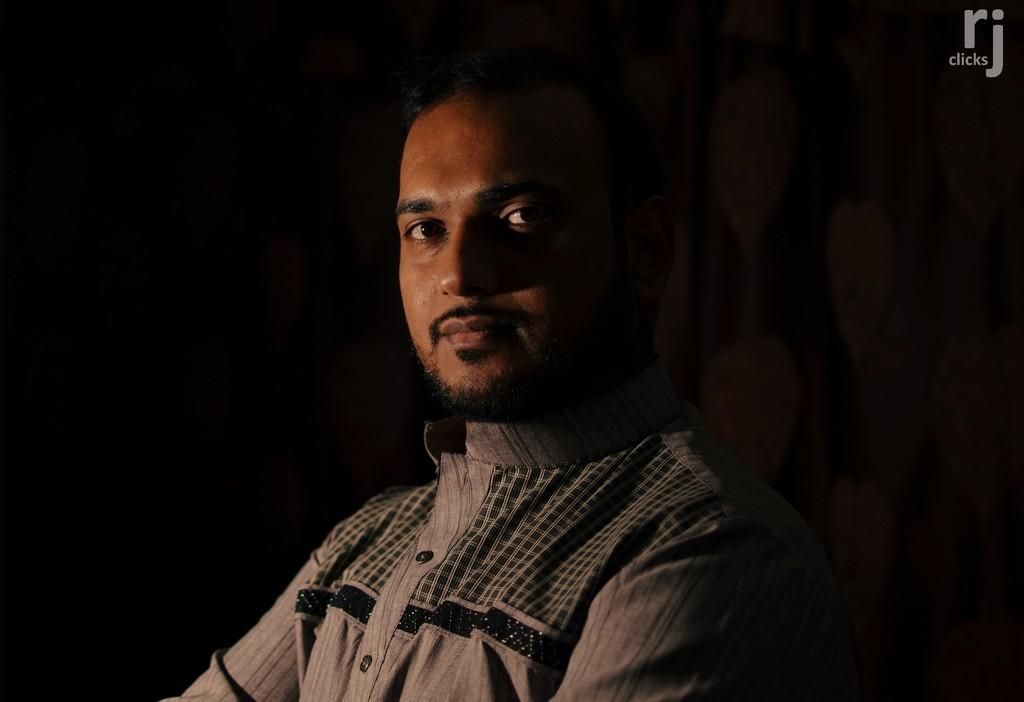What can be seen in the image? There is a person in the image. What is the person wearing? The person is wearing a shirt. How would you describe the background of the image? The background of the image is dark. Is there any additional information or markings on the image? Yes, there is a watermark at the top right side of the image. How far away is the person's tail in the image? There is no tail present in the image, as the subject is a person. 